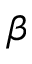<formula> <loc_0><loc_0><loc_500><loc_500>\beta</formula> 